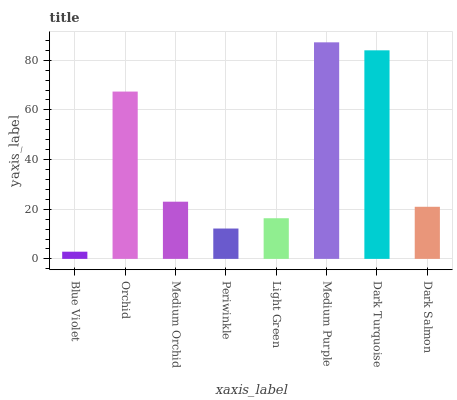Is Blue Violet the minimum?
Answer yes or no. Yes. Is Medium Purple the maximum?
Answer yes or no. Yes. Is Orchid the minimum?
Answer yes or no. No. Is Orchid the maximum?
Answer yes or no. No. Is Orchid greater than Blue Violet?
Answer yes or no. Yes. Is Blue Violet less than Orchid?
Answer yes or no. Yes. Is Blue Violet greater than Orchid?
Answer yes or no. No. Is Orchid less than Blue Violet?
Answer yes or no. No. Is Medium Orchid the high median?
Answer yes or no. Yes. Is Dark Salmon the low median?
Answer yes or no. Yes. Is Orchid the high median?
Answer yes or no. No. Is Orchid the low median?
Answer yes or no. No. 